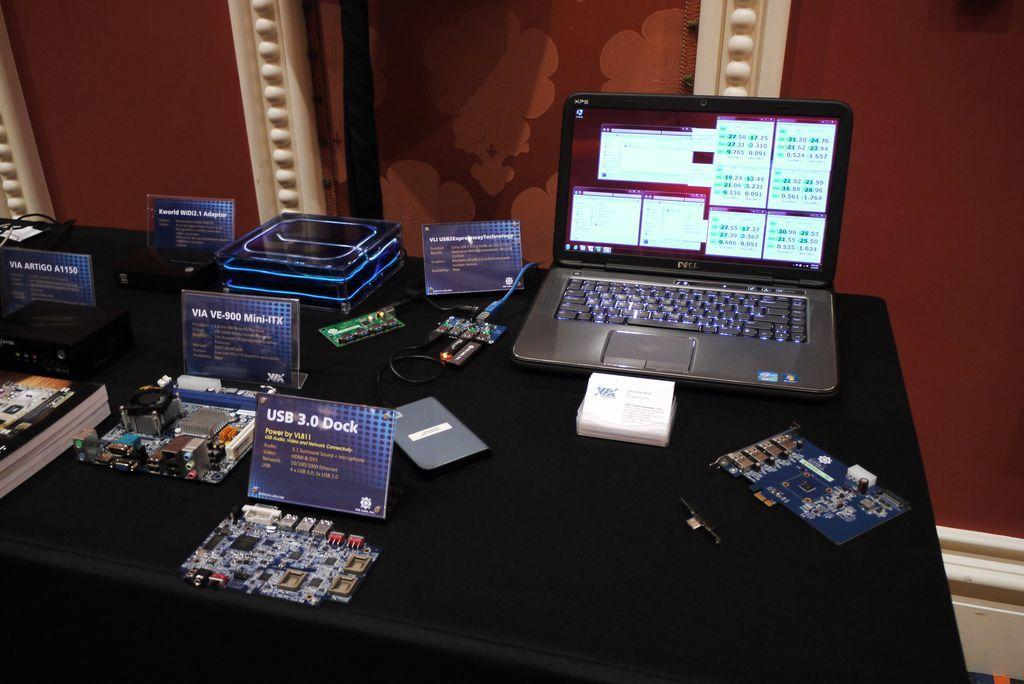<image>
Give a short and clear explanation of the subsequent image. A laptop computer made by Dell open on a table 